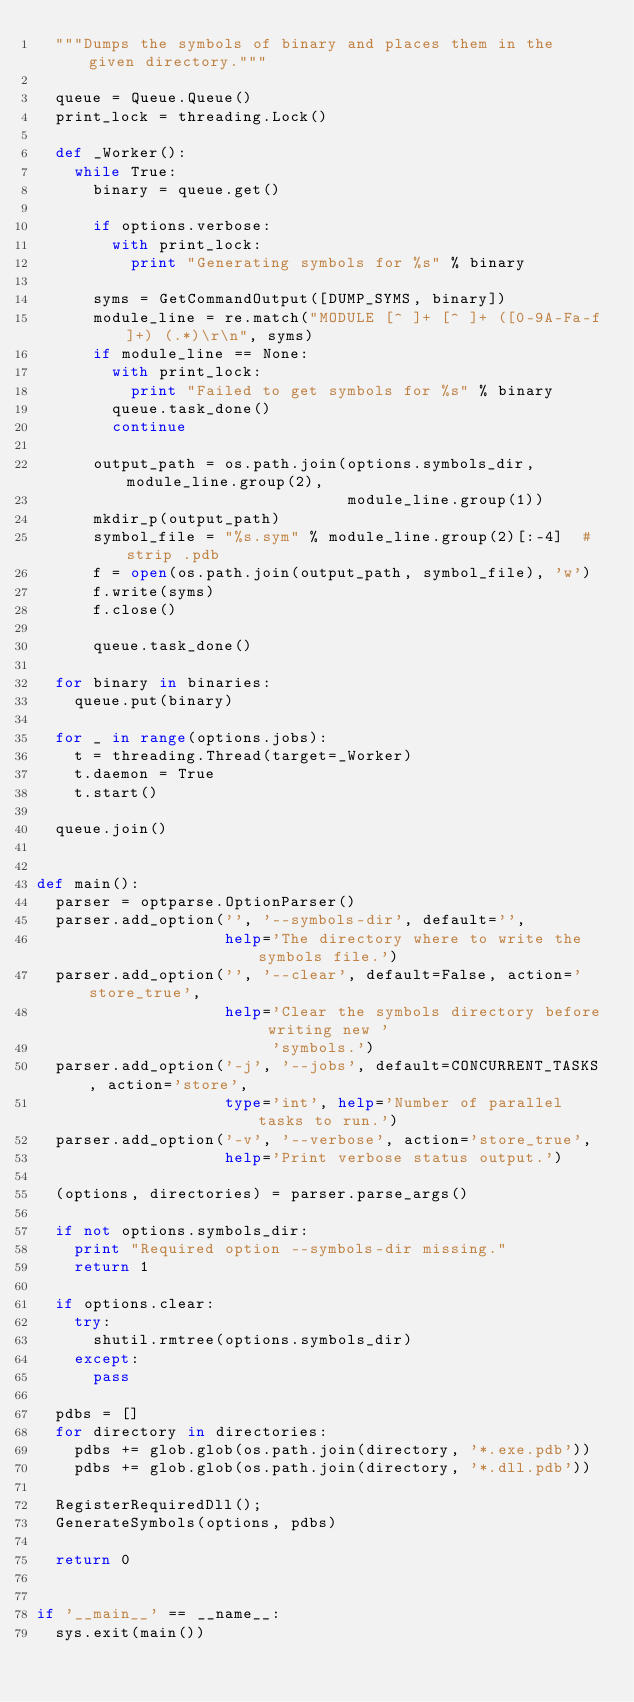Convert code to text. <code><loc_0><loc_0><loc_500><loc_500><_Python_>  """Dumps the symbols of binary and places them in the given directory."""

  queue = Queue.Queue()
  print_lock = threading.Lock()

  def _Worker():
    while True:
      binary = queue.get()

      if options.verbose:
        with print_lock:
          print "Generating symbols for %s" % binary

      syms = GetCommandOutput([DUMP_SYMS, binary])
      module_line = re.match("MODULE [^ ]+ [^ ]+ ([0-9A-Fa-f]+) (.*)\r\n", syms)
      if module_line == None:
        with print_lock:
          print "Failed to get symbols for %s" % binary
        queue.task_done()
        continue

      output_path = os.path.join(options.symbols_dir, module_line.group(2),
                                 module_line.group(1))
      mkdir_p(output_path)
      symbol_file = "%s.sym" % module_line.group(2)[:-4]  # strip .pdb
      f = open(os.path.join(output_path, symbol_file), 'w')
      f.write(syms)
      f.close()

      queue.task_done()

  for binary in binaries:
    queue.put(binary)

  for _ in range(options.jobs):
    t = threading.Thread(target=_Worker)
    t.daemon = True
    t.start()

  queue.join()


def main():
  parser = optparse.OptionParser()
  parser.add_option('', '--symbols-dir', default='',
                    help='The directory where to write the symbols file.')
  parser.add_option('', '--clear', default=False, action='store_true',
                    help='Clear the symbols directory before writing new '
                         'symbols.')
  parser.add_option('-j', '--jobs', default=CONCURRENT_TASKS, action='store',
                    type='int', help='Number of parallel tasks to run.')
  parser.add_option('-v', '--verbose', action='store_true',
                    help='Print verbose status output.')

  (options, directories) = parser.parse_args()

  if not options.symbols_dir:
    print "Required option --symbols-dir missing."
    return 1

  if options.clear:
    try:
      shutil.rmtree(options.symbols_dir)
    except:
      pass

  pdbs = []
  for directory in directories:
    pdbs += glob.glob(os.path.join(directory, '*.exe.pdb'))
    pdbs += glob.glob(os.path.join(directory, '*.dll.pdb'))

  RegisterRequiredDll();
  GenerateSymbols(options, pdbs)

  return 0


if '__main__' == __name__:
  sys.exit(main())
</code> 